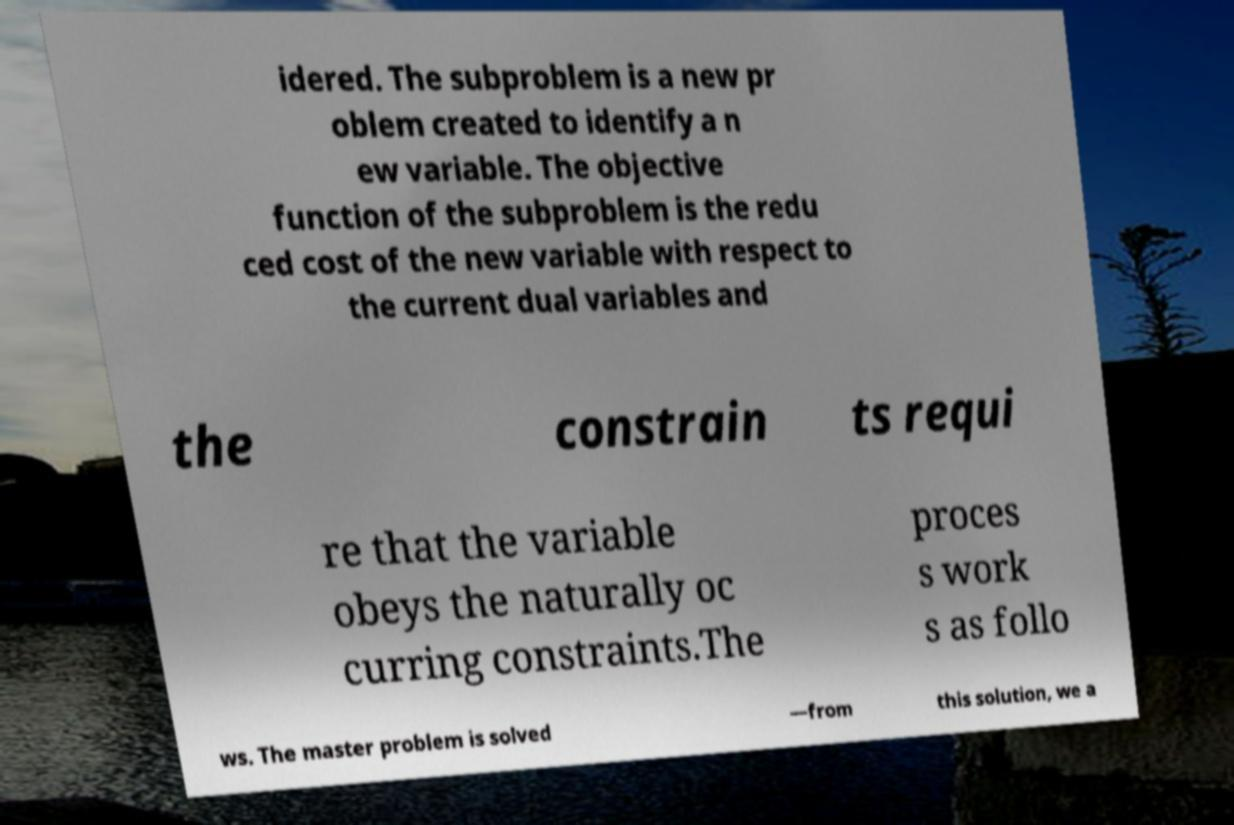Please read and relay the text visible in this image. What does it say? idered. The subproblem is a new pr oblem created to identify a n ew variable. The objective function of the subproblem is the redu ced cost of the new variable with respect to the current dual variables and the constrain ts requi re that the variable obeys the naturally oc curring constraints.The proces s work s as follo ws. The master problem is solved —from this solution, we a 